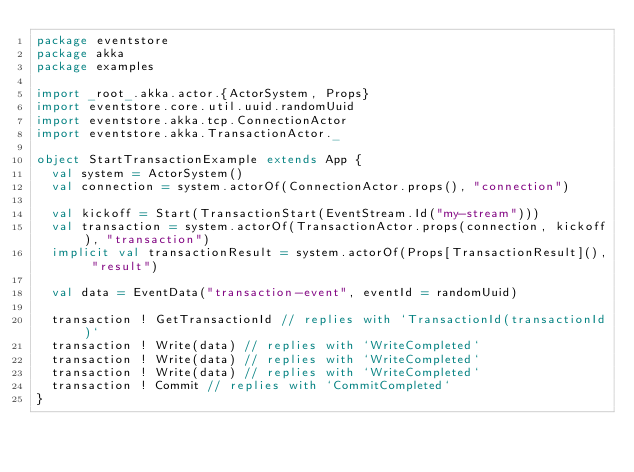Convert code to text. <code><loc_0><loc_0><loc_500><loc_500><_Scala_>package eventstore
package akka
package examples

import _root_.akka.actor.{ActorSystem, Props}
import eventstore.core.util.uuid.randomUuid
import eventstore.akka.tcp.ConnectionActor
import eventstore.akka.TransactionActor._

object StartTransactionExample extends App {
  val system = ActorSystem()
  val connection = system.actorOf(ConnectionActor.props(), "connection")

  val kickoff = Start(TransactionStart(EventStream.Id("my-stream")))
  val transaction = system.actorOf(TransactionActor.props(connection, kickoff), "transaction")
  implicit val transactionResult = system.actorOf(Props[TransactionResult](), "result")

  val data = EventData("transaction-event", eventId = randomUuid)

  transaction ! GetTransactionId // replies with `TransactionId(transactionId)`
  transaction ! Write(data) // replies with `WriteCompleted`
  transaction ! Write(data) // replies with `WriteCompleted`
  transaction ! Write(data) // replies with `WriteCompleted`
  transaction ! Commit // replies with `CommitCompleted`
}</code> 